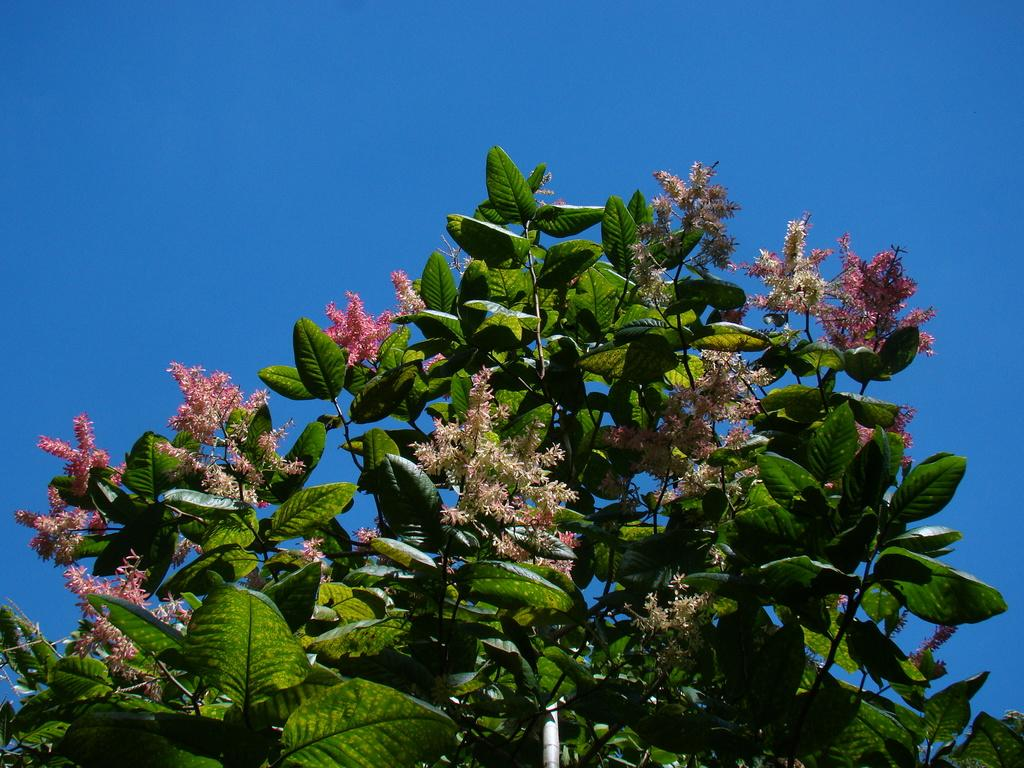What type of plants can be seen in the image? There are flowers and leaves in the image. What can be seen in the background of the image? The sky is visible in the background of the image. How do the dinosaurs interact with the flowers in the image? There are no dinosaurs present in the image; it features flowers and leaves. What type of behavior can be observed in the image? The image does not depict any behavior, as it only shows flowers, leaves, and the sky. 